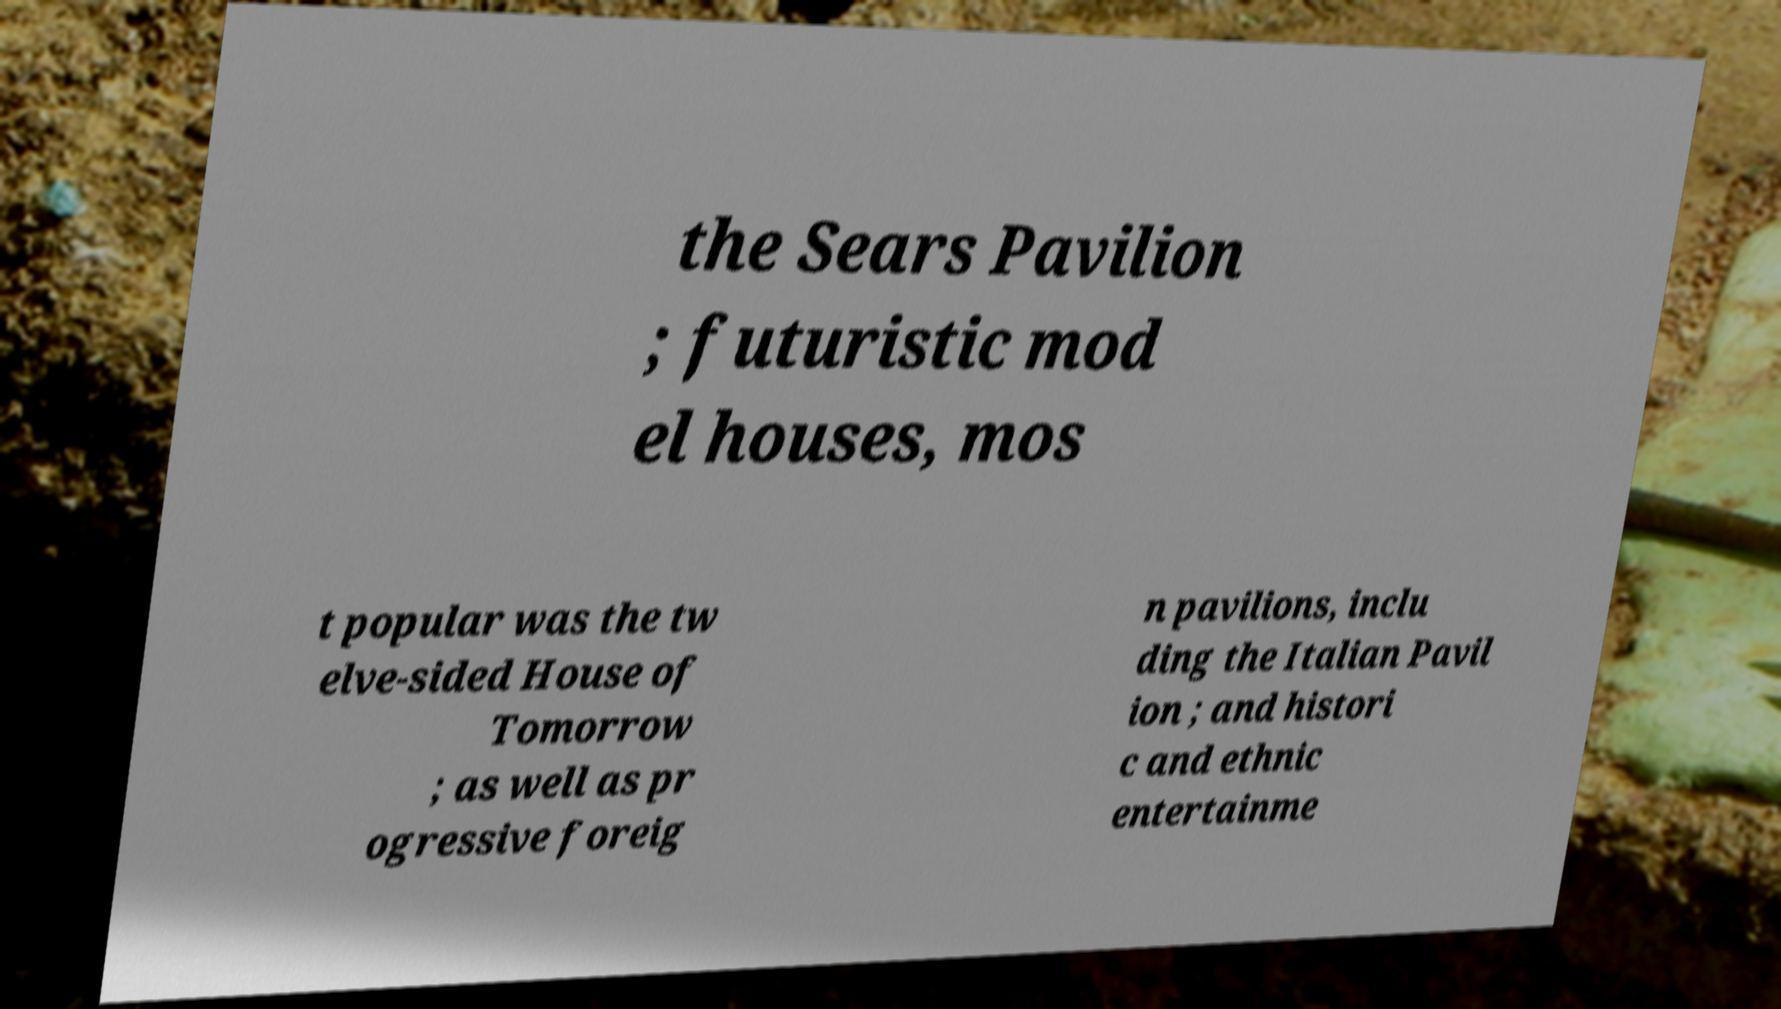There's text embedded in this image that I need extracted. Can you transcribe it verbatim? the Sears Pavilion ; futuristic mod el houses, mos t popular was the tw elve-sided House of Tomorrow ; as well as pr ogressive foreig n pavilions, inclu ding the Italian Pavil ion ; and histori c and ethnic entertainme 